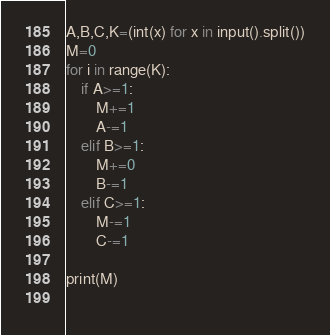Convert code to text. <code><loc_0><loc_0><loc_500><loc_500><_Python_>A,B,C,K=(int(x) for x in input().split())
M=0
for i in range(K):
    if A>=1:
        M+=1
        A-=1
    elif B>=1:
        M+=0
        B-=1
    elif C>=1:
        M-=1
        C-=1
    
print(M)
    </code> 